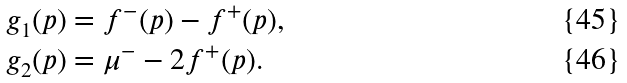<formula> <loc_0><loc_0><loc_500><loc_500>g _ { 1 } ( p ) & = f ^ { - } ( p ) - f ^ { + } ( p ) , \\ g _ { 2 } ( p ) & = \mu ^ { - } - 2 f ^ { + } ( p ) .</formula> 